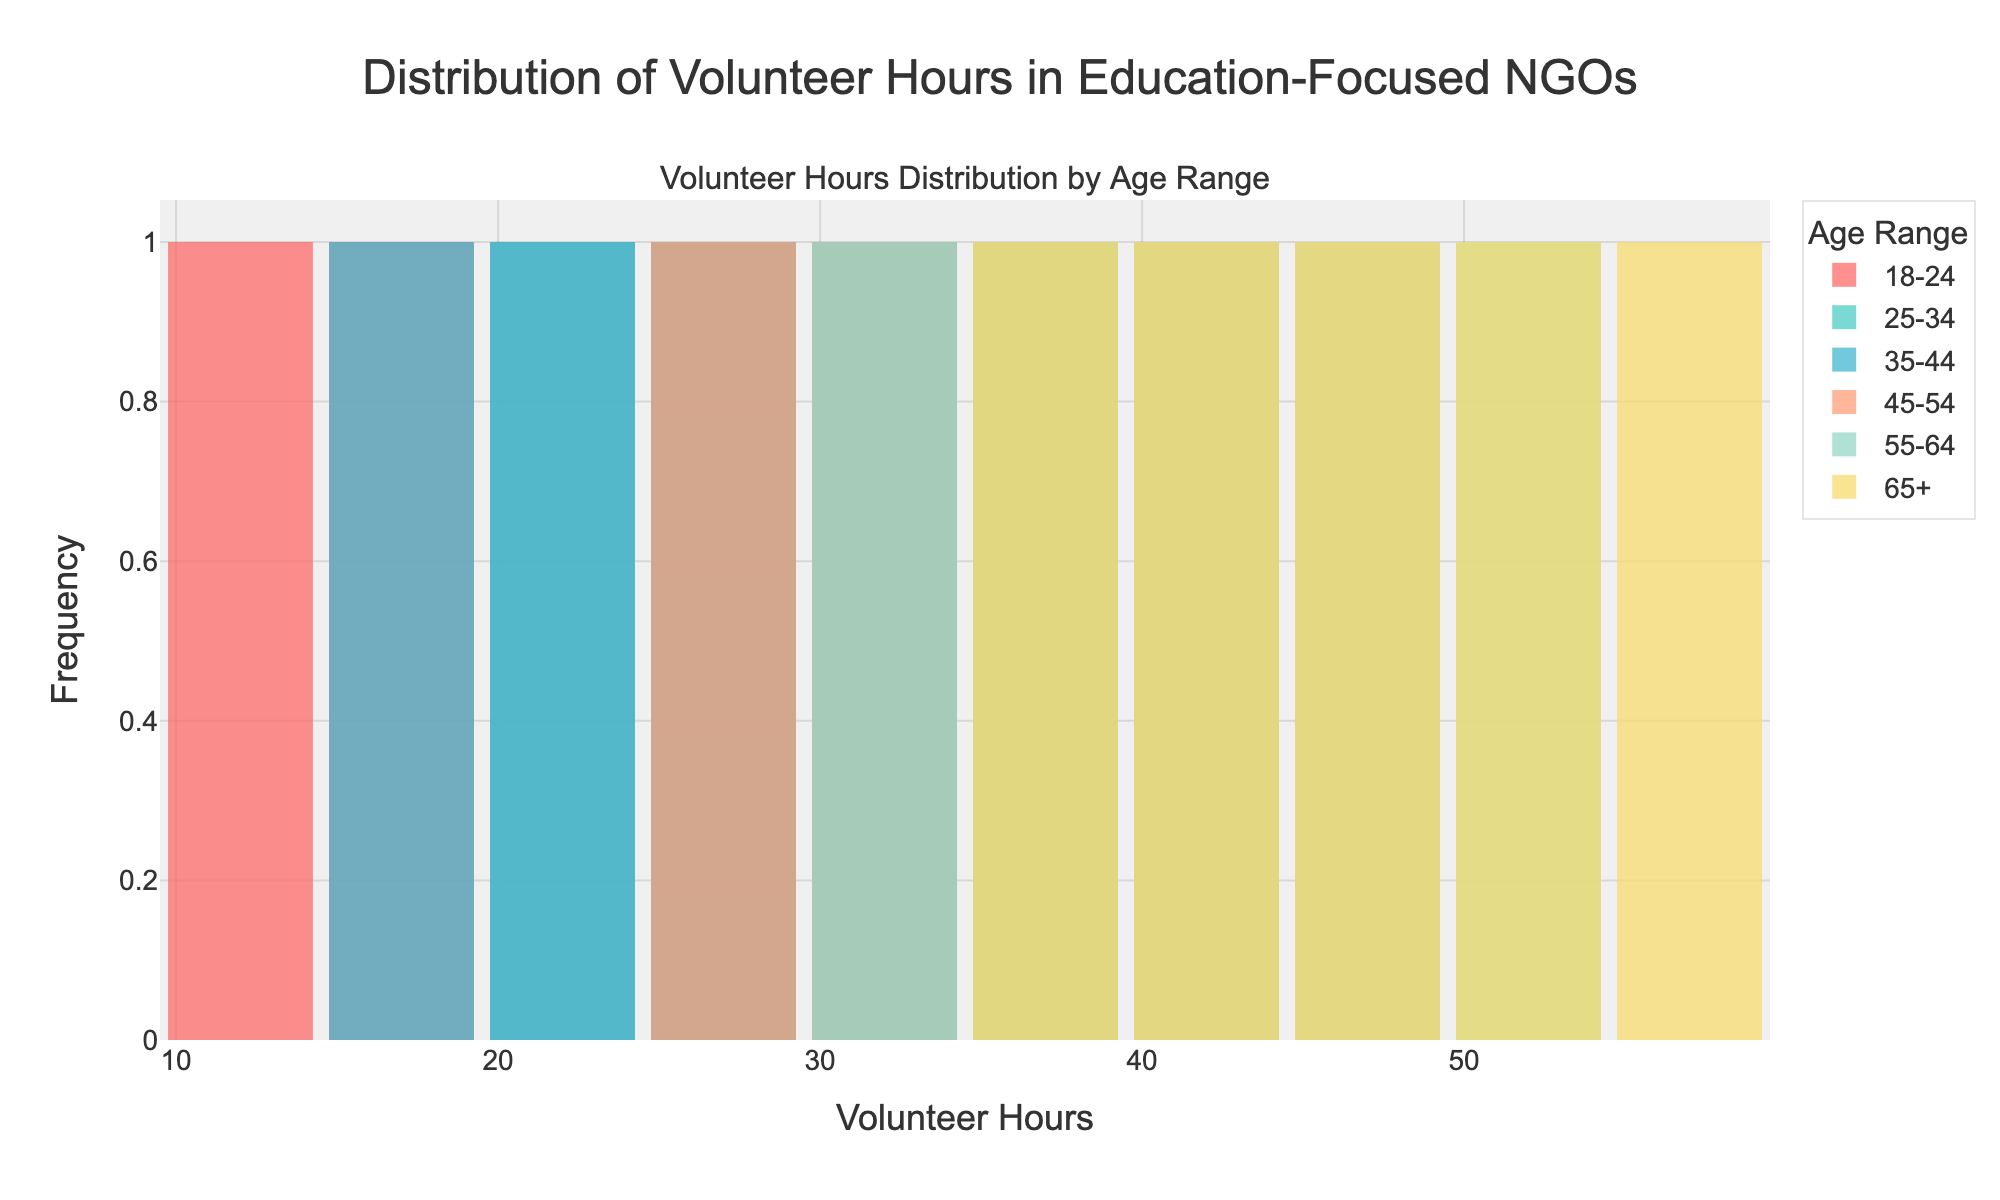Which age range has the widest spread of volunteer hours? The age range whose histogram bars are spread out over the widest range of volunteer hours is the one with the widest spread. Look at the width from the minimum to the maximum hours for each age range.
Answer: 65+ Which age range has the most concentrated volunteer hours around 30 hours? Check which age range has the highest histogram bar around 30 hours, indicating most volunteer hours are concentrated around this value.
Answer: 25-34 What is the maximum number of volunteer hours contributed by the 18-24 age group? Identify the maximum value on the x-axis for the histogram bars of the 18-24 age range.
Answer: 30 Which age range contributes the least volunteer hours regularly, as seen in the histogram? Look for the age range with the histogram bars positioned lower on the x-axis, indicating fewer volunteer hours.
Answer: 18-24 How do volunteer hours for the age range 55-64 compare to those of 45-54? Compare the height of the histogram bars for the two age ranges at several points, especially noting if 55-64 has more bars on the higher end of hours.
Answer: 55-64 contributes more hours Which age range has bars indicating steady increases in volunteer hours? Look for age ranges where the histogram bars show a consistent upward trend, indicating increasing hours.
Answer: 65+ What's the most frequent volunteer hour range for the 35-44 age group? Identify the tallest histogram bar for the 35-44 age range, which indicates the most frequent volunteer hours.
Answer: 25-30 Do older age groups (65+ and 55-64) contribute higher volunteer hours compared to younger groups (18-24, 25-34)? Compare the histogram bars of older age groups to those of younger groups, focusing on higher ranges of volunteer hours.
Answer: Yes Is there any age range where volunteer hours are almost evenly distributed across the bins? Look for an age range where histogram bars have similar heights, indicating an even distribution.
Answer: 35-44 